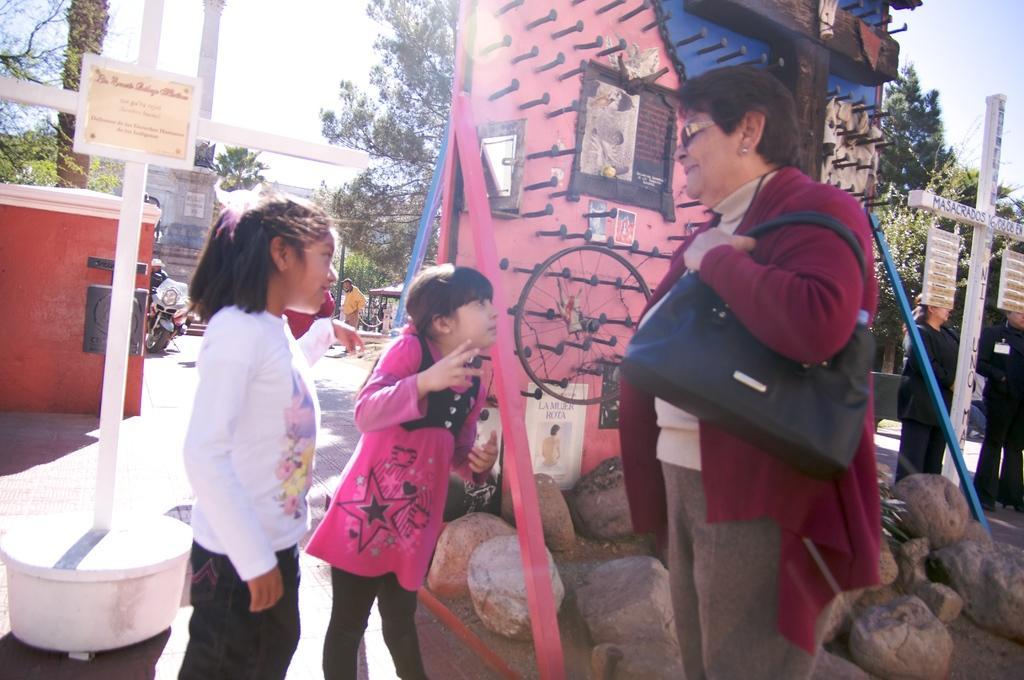Describe this image in one or two sentences. There is a lady wearing bag and specs is standing. Near to her two children are standing. On the ground there are rocks. Also there is a wall with nails and many other things. There are poles. On the left side there is a board with poles. In the back there are trees. Also there is a motorcycle. And there is a wall. In the background there is sky. 